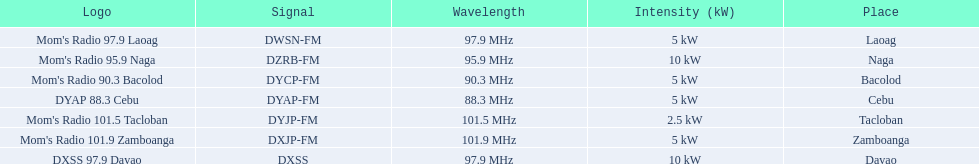Which stations use less than 10kw of power? Mom's Radio 97.9 Laoag, Mom's Radio 90.3 Bacolod, DYAP 88.3 Cebu, Mom's Radio 101.5 Tacloban, Mom's Radio 101.9 Zamboanga. Do any stations use less than 5kw of power? if so, which ones? Mom's Radio 101.5 Tacloban. 